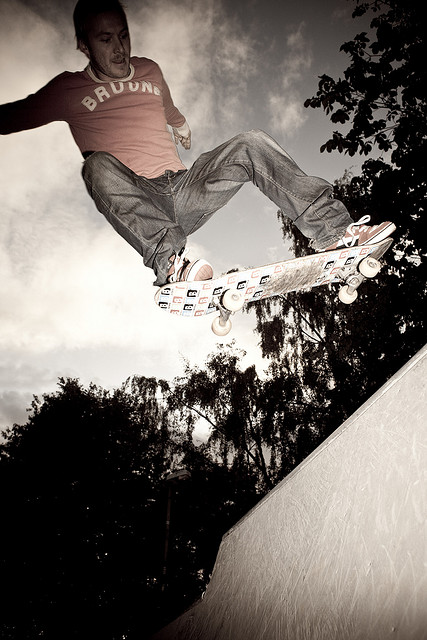Identify the text contained in this image. BRUUN 